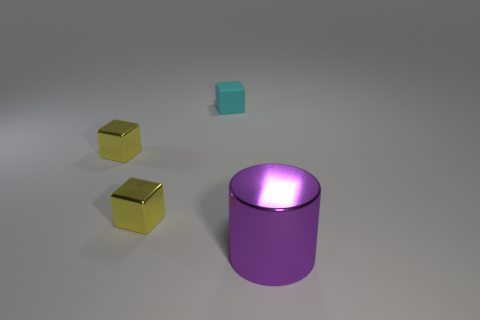Add 3 purple shiny things. How many objects exist? 7 Subtract all cubes. How many objects are left? 1 Subtract all small yellow metal cubes. Subtract all small matte cubes. How many objects are left? 1 Add 3 metal objects. How many metal objects are left? 6 Add 1 small cyan objects. How many small cyan objects exist? 2 Subtract 0 gray spheres. How many objects are left? 4 